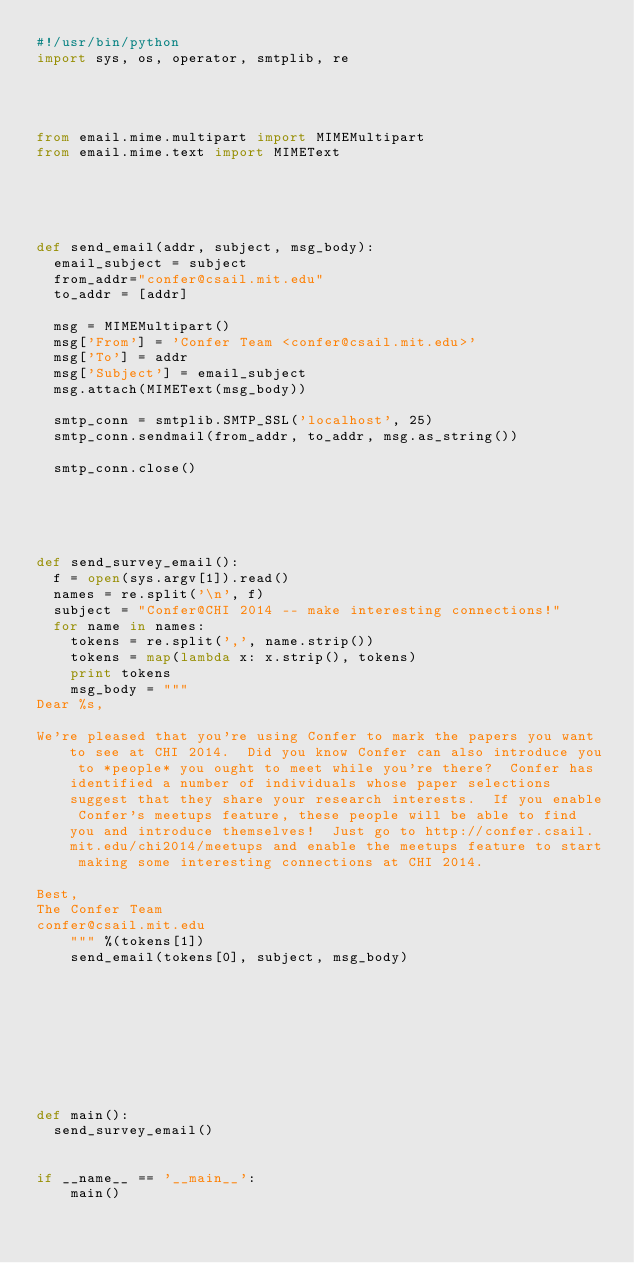<code> <loc_0><loc_0><loc_500><loc_500><_Python_>#!/usr/bin/python
import sys, os, operator, smtplib, re




from email.mime.multipart import MIMEMultipart
from email.mime.text import MIMEText





def send_email(addr, subject, msg_body):	
	email_subject = subject
	from_addr="confer@csail.mit.edu"
	to_addr = [addr]
	
	msg = MIMEMultipart()
	msg['From'] = 'Confer Team <confer@csail.mit.edu>'
	msg['To'] = addr
	msg['Subject'] = email_subject
	msg.attach(MIMEText(msg_body))	
	
	smtp_conn = smtplib.SMTP_SSL('localhost', 25)	
	smtp_conn.sendmail(from_addr, to_addr, msg.as_string())
	
	smtp_conn.close() 





def send_survey_email():
	f = open(sys.argv[1]).read()
	names = re.split('\n', f)
	subject = "Confer@CHI 2014 -- make interesting connections!"
	for name in names:
		tokens = re.split(',', name.strip())
		tokens = map(lambda x: x.strip(), tokens)
		print tokens
		msg_body = """
Dear %s,

We're pleased that you're using Confer to mark the papers you want to see at CHI 2014.  Did you know Confer can also introduce you to *people* you ought to meet while you're there?  Confer has identified a number of individuals whose paper selections suggest that they share your research interests.  If you enable Confer's meetups feature, these people will be able to find you and introduce themselves!  Just go to http://confer.csail.mit.edu/chi2014/meetups and enable the meetups feature to start making some interesting connections at CHI 2014.

Best,
The Confer Team
confer@csail.mit.edu
		""" %(tokens[1])
		send_email(tokens[0], subject, msg_body)
		
	
	






def main():
	send_survey_email()
	

if __name__ == '__main__':
    main()
</code> 